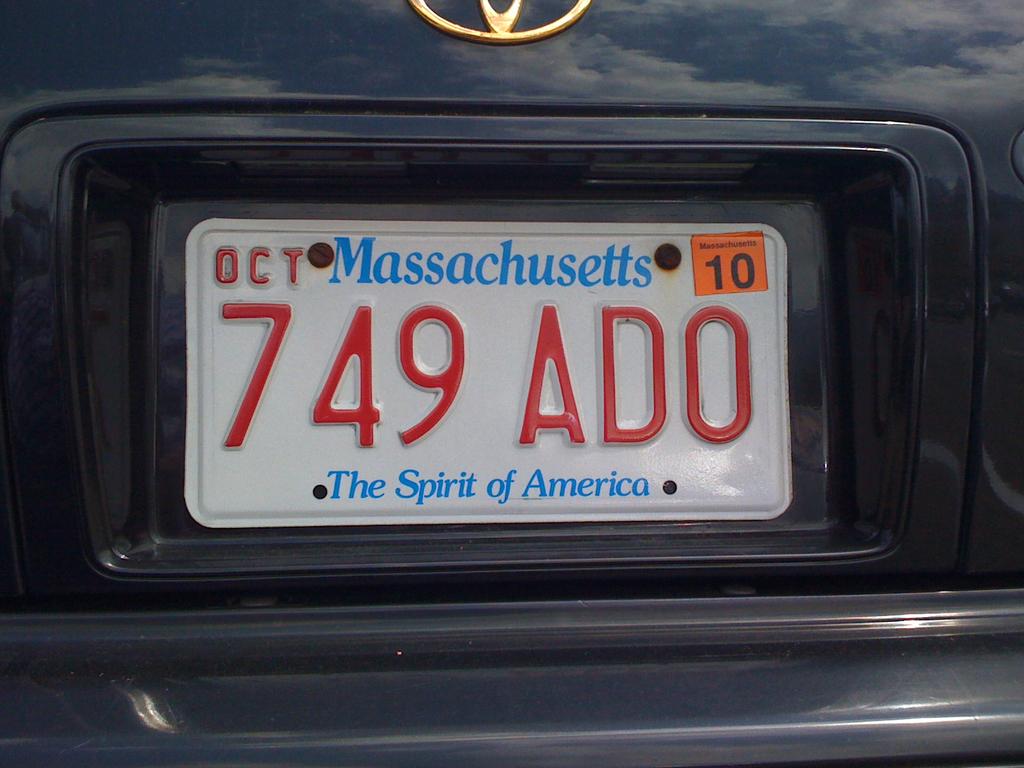What state is this car from?
Give a very brief answer. Massachusetts. What is the plate number?
Offer a very short reply. 749 ado. 